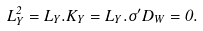<formula> <loc_0><loc_0><loc_500><loc_500>L _ { Y } ^ { 2 } = L _ { Y } . K _ { Y } = L _ { Y } . \sigma ^ { \prime } D _ { W } = 0 .</formula> 